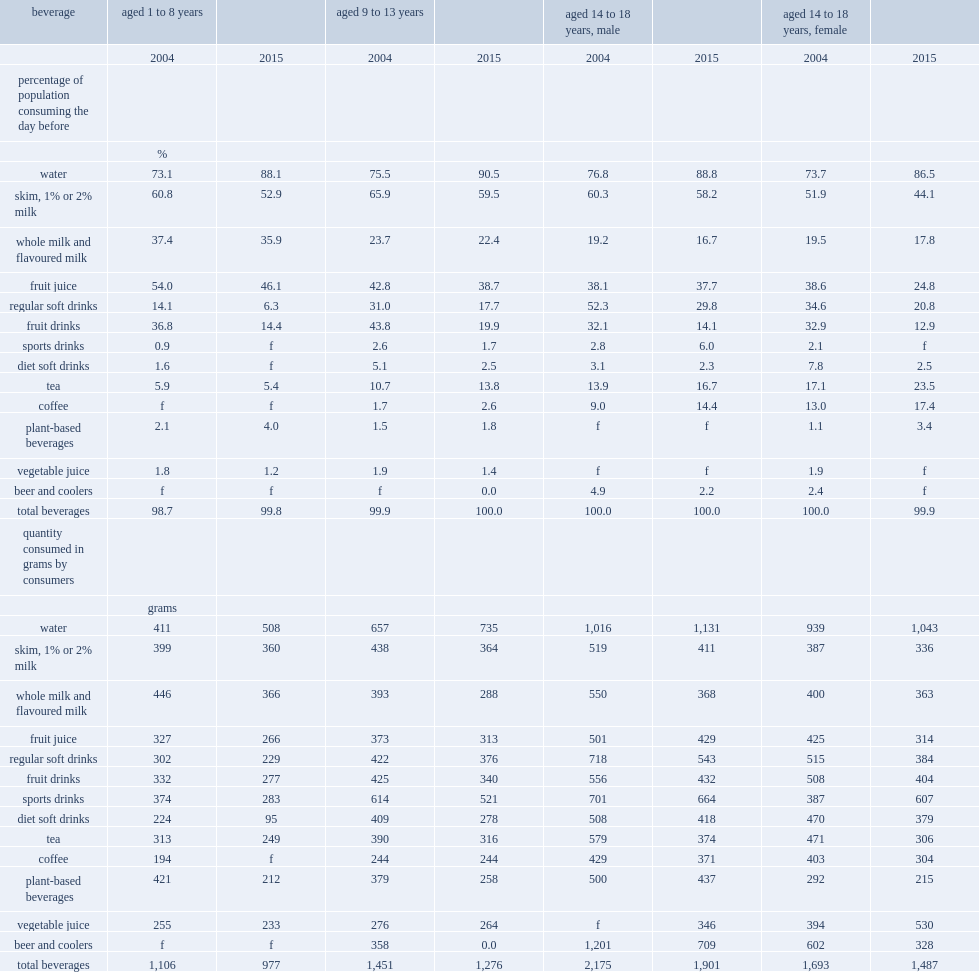What is the fifth most commonly consumed beverages among teenagers aged 14 to 18 in 2015? Tea. What is the average percentage of children and teenagers drinking water in 2015? 88.475. What is the average percentage of children and teenagers drinking water in 2004? 74.775. 